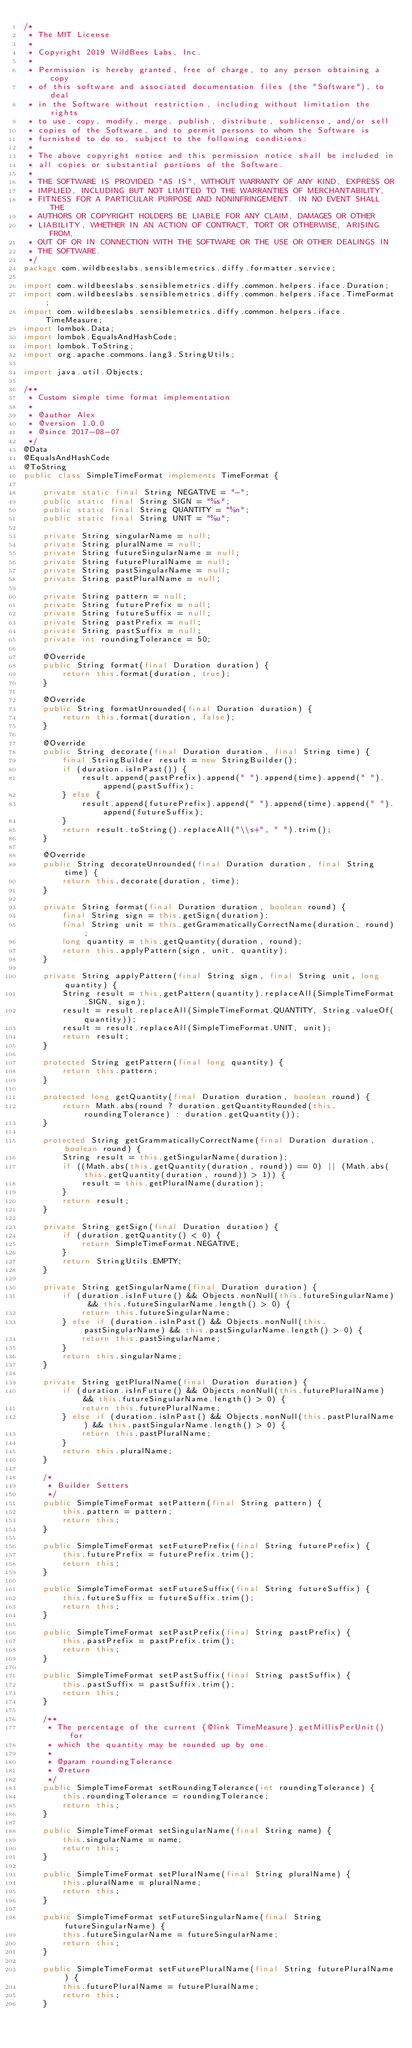<code> <loc_0><loc_0><loc_500><loc_500><_Java_>/*
 * The MIT License
 *
 * Copyright 2019 WildBees Labs, Inc.
 *
 * Permission is hereby granted, free of charge, to any person obtaining a copy
 * of this software and associated documentation files (the "Software"), to deal
 * in the Software without restriction, including without limitation the rights
 * to use, copy, modify, merge, publish, distribute, sublicense, and/or sell
 * copies of the Software, and to permit persons to whom the Software is
 * furnished to do so, subject to the following conditions:
 *
 * The above copyright notice and this permission notice shall be included in
 * all copies or substantial portions of the Software.
 *
 * THE SOFTWARE IS PROVIDED "AS IS", WITHOUT WARRANTY OF ANY KIND, EXPRESS OR
 * IMPLIED, INCLUDING BUT NOT LIMITED TO THE WARRANTIES OF MERCHANTABILITY,
 * FITNESS FOR A PARTICULAR PURPOSE AND NONINFRINGEMENT. IN NO EVENT SHALL THE
 * AUTHORS OR COPYRIGHT HOLDERS BE LIABLE FOR ANY CLAIM, DAMAGES OR OTHER
 * LIABILITY, WHETHER IN AN ACTION OF CONTRACT, TORT OR OTHERWISE, ARISING FROM,
 * OUT OF OR IN CONNECTION WITH THE SOFTWARE OR THE USE OR OTHER DEALINGS IN
 * THE SOFTWARE.
 */
package com.wildbeeslabs.sensiblemetrics.diffy.formatter.service;

import com.wildbeeslabs.sensiblemetrics.diffy.common.helpers.iface.Duration;
import com.wildbeeslabs.sensiblemetrics.diffy.common.helpers.iface.TimeFormat;
import com.wildbeeslabs.sensiblemetrics.diffy.common.helpers.iface.TimeMeasure;
import lombok.Data;
import lombok.EqualsAndHashCode;
import lombok.ToString;
import org.apache.commons.lang3.StringUtils;

import java.util.Objects;

/**
 * Custom simple time format implementation
 *
 * @author Alex
 * @version 1.0.0
 * @since 2017-08-07
 */
@Data
@EqualsAndHashCode
@ToString
public class SimpleTimeFormat implements TimeFormat {

    private static final String NEGATIVE = "-";
    public static final String SIGN = "%s";
    public static final String QUANTITY = "%n";
    public static final String UNIT = "%u";

    private String singularName = null;
    private String pluralName = null;
    private String futureSingularName = null;
    private String futurePluralName = null;
    private String pastSingularName = null;
    private String pastPluralName = null;

    private String pattern = null;
    private String futurePrefix = null;
    private String futureSuffix = null;
    private String pastPrefix = null;
    private String pastSuffix = null;
    private int roundingTolerance = 50;

    @Override
    public String format(final Duration duration) {
        return this.format(duration, true);
    }

    @Override
    public String formatUnrounded(final Duration duration) {
        return this.format(duration, false);
    }

    @Override
    public String decorate(final Duration duration, final String time) {
        final StringBuilder result = new StringBuilder();
        if (duration.isInPast()) {
            result.append(pastPrefix).append(" ").append(time).append(" ").append(pastSuffix);
        } else {
            result.append(futurePrefix).append(" ").append(time).append(" ").append(futureSuffix);
        }
        return result.toString().replaceAll("\\s+", " ").trim();
    }

    @Override
    public String decorateUnrounded(final Duration duration, final String time) {
        return this.decorate(duration, time);
    }

    private String format(final Duration duration, boolean round) {
        final String sign = this.getSign(duration);
        final String unit = this.getGrammaticallyCorrectName(duration, round);
        long quantity = this.getQuantity(duration, round);
        return this.applyPattern(sign, unit, quantity);
    }

    private String applyPattern(final String sign, final String unit, long quantity) {
        String result = this.getPattern(quantity).replaceAll(SimpleTimeFormat.SIGN, sign);
        result = result.replaceAll(SimpleTimeFormat.QUANTITY, String.valueOf(quantity));
        result = result.replaceAll(SimpleTimeFormat.UNIT, unit);
        return result;
    }

    protected String getPattern(final long quantity) {
        return this.pattern;
    }

    protected long getQuantity(final Duration duration, boolean round) {
        return Math.abs(round ? duration.getQuantityRounded(this.roundingTolerance) : duration.getQuantity());
    }

    protected String getGrammaticallyCorrectName(final Duration duration, boolean round) {
        String result = this.getSingularName(duration);
        if ((Math.abs(this.getQuantity(duration, round)) == 0) || (Math.abs(this.getQuantity(duration, round)) > 1)) {
            result = this.getPluralName(duration);
        }
        return result;
    }

    private String getSign(final Duration duration) {
        if (duration.getQuantity() < 0) {
            return SimpleTimeFormat.NEGATIVE;
        }
        return StringUtils.EMPTY;
    }

    private String getSingularName(final Duration duration) {
        if (duration.isInFuture() && Objects.nonNull(this.futureSingularName) && this.futureSingularName.length() > 0) {
            return this.futureSingularName;
        } else if (duration.isInPast() && Objects.nonNull(this.pastSingularName) && this.pastSingularName.length() > 0) {
            return this.pastSingularName;
        }
        return this.singularName;
    }

    private String getPluralName(final Duration duration) {
        if (duration.isInFuture() && Objects.nonNull(this.futurePluralName) && this.futureSingularName.length() > 0) {
            return this.futurePluralName;
        } else if (duration.isInPast() && Objects.nonNull(this.pastPluralName) && this.pastSingularName.length() > 0) {
            return this.pastPluralName;
        }
        return this.pluralName;
    }

    /*
     * Builder Setters
     */
    public SimpleTimeFormat setPattern(final String pattern) {
        this.pattern = pattern;
        return this;
    }

    public SimpleTimeFormat setFuturePrefix(final String futurePrefix) {
        this.futurePrefix = futurePrefix.trim();
        return this;
    }

    public SimpleTimeFormat setFutureSuffix(final String futureSuffix) {
        this.futureSuffix = futureSuffix.trim();
        return this;
    }

    public SimpleTimeFormat setPastPrefix(final String pastPrefix) {
        this.pastPrefix = pastPrefix.trim();
        return this;
    }

    public SimpleTimeFormat setPastSuffix(final String pastSuffix) {
        this.pastSuffix = pastSuffix.trim();
        return this;
    }

    /**
     * The percentage of the current {@link TimeMeasure}.getMillisPerUnit() for
     * which the quantity may be rounded up by one.
     *
     * @param roundingTolerance
     * @return
     */
    public SimpleTimeFormat setRoundingTolerance(int roundingTolerance) {
        this.roundingTolerance = roundingTolerance;
        return this;
    }

    public SimpleTimeFormat setSingularName(final String name) {
        this.singularName = name;
        return this;
    }

    public SimpleTimeFormat setPluralName(final String pluralName) {
        this.pluralName = pluralName;
        return this;
    }

    public SimpleTimeFormat setFutureSingularName(final String futureSingularName) {
        this.futureSingularName = futureSingularName;
        return this;
    }

    public SimpleTimeFormat setFuturePluralName(final String futurePluralName) {
        this.futurePluralName = futurePluralName;
        return this;
    }
</code> 